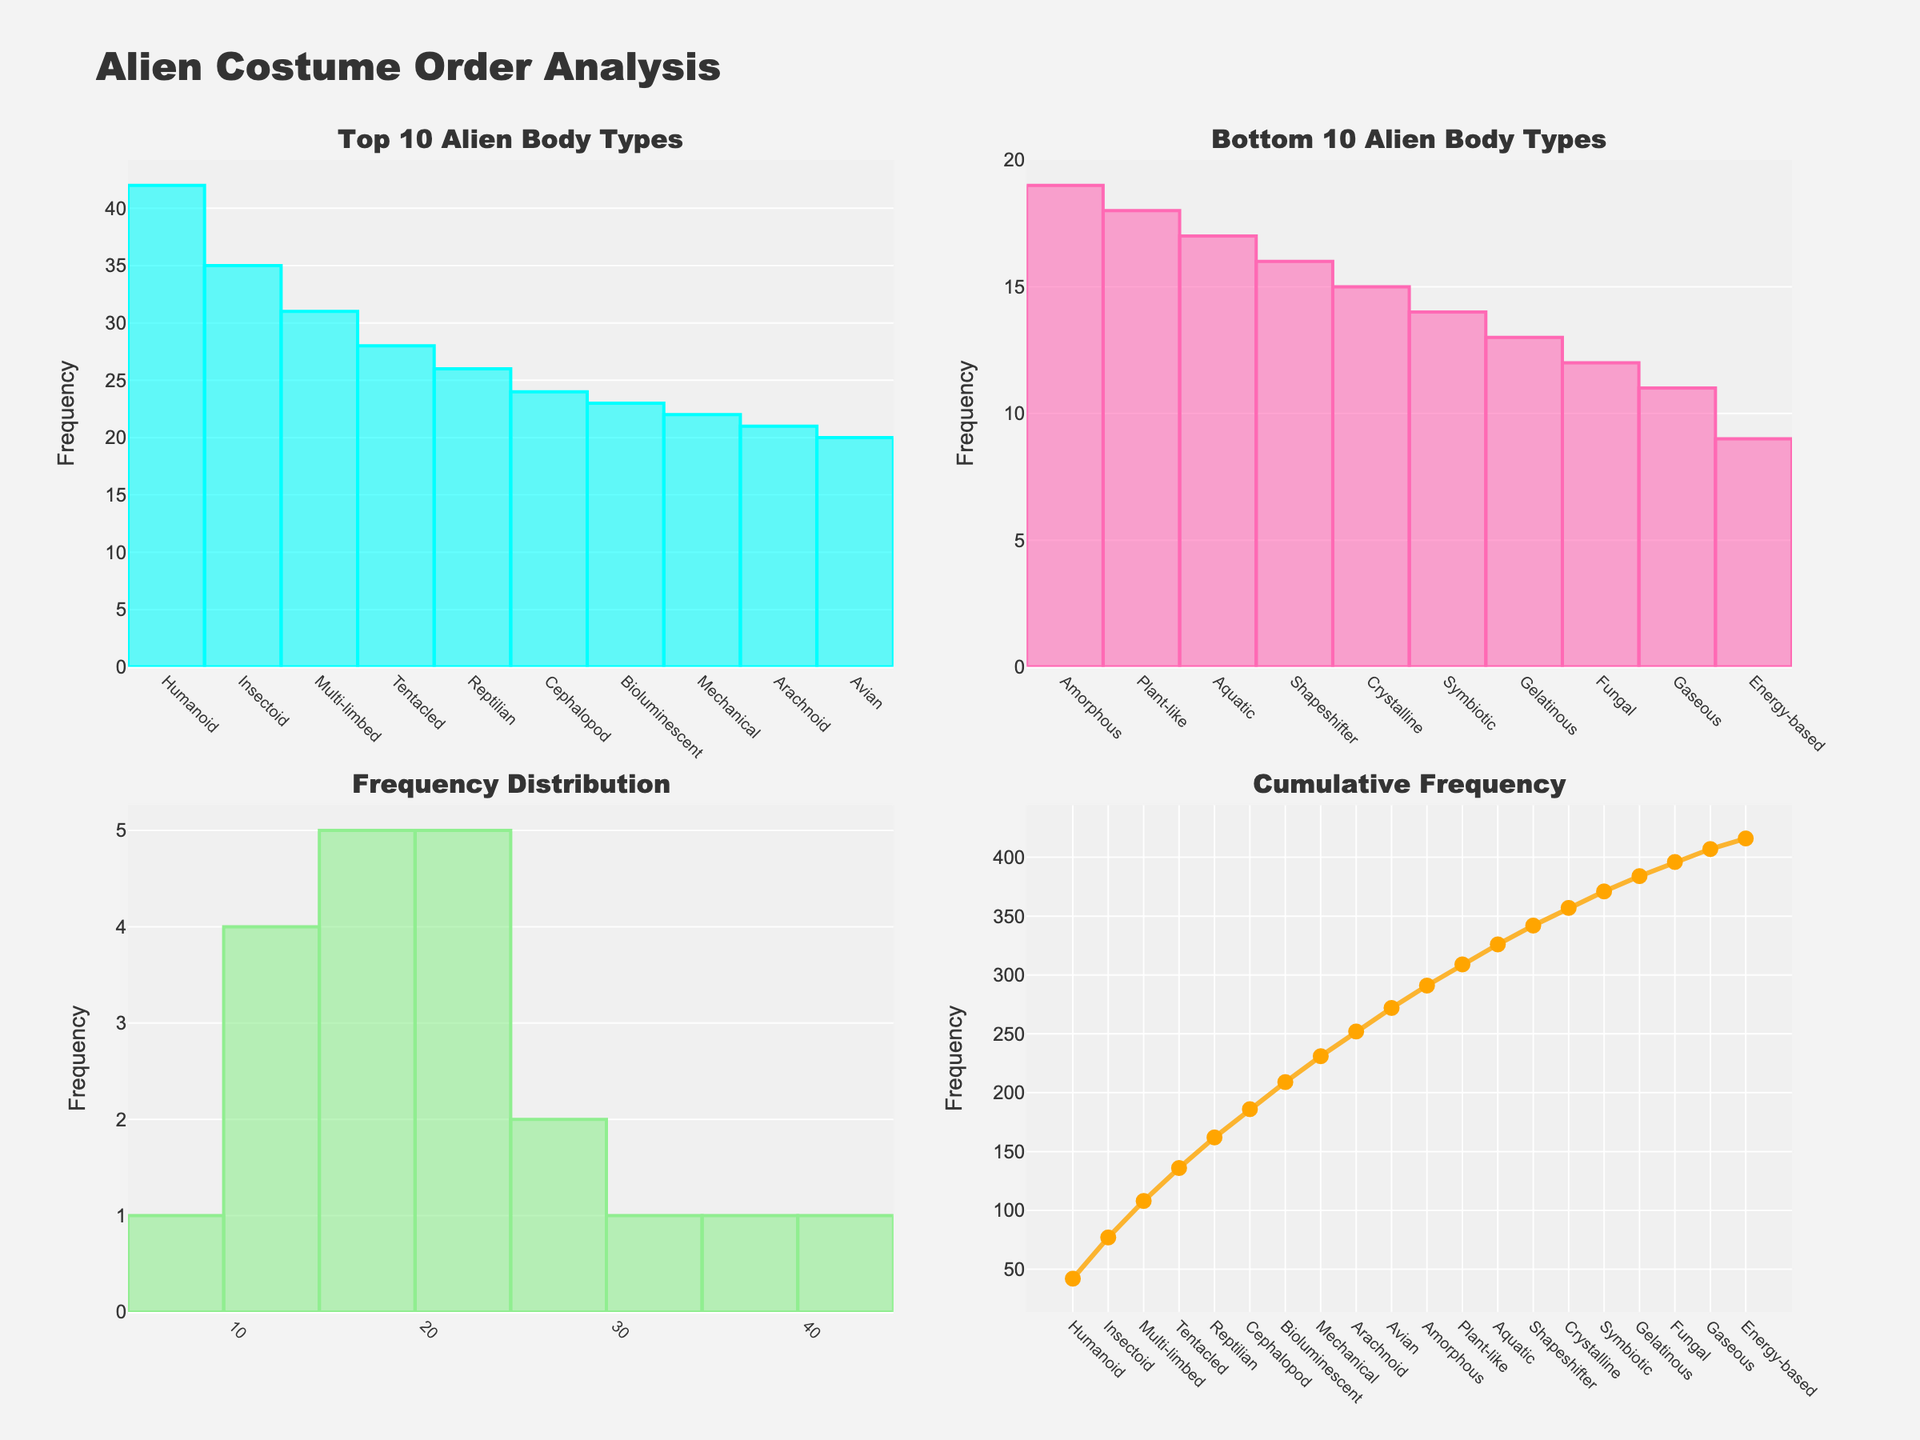What is the most common alien body type in the top 10 categories? Refer to the bar plot in the "Top 10 Alien Body Types" subplot. The tallest bar represents the most common body type, which is Humanoid with a frequency of 42.
Answer: Humanoid Which alien body type has the lowest frequency in the bottom 10 categories? Look at the bar plot in the "Bottom 10 Alien Body Types" subplot. The shortest bar represents the least common body type, which is Energy-based with a frequency of 9.
Answer: Energy-based How many alien body types are there in total? Count the number of unique body types represented in either the "Top 10 Alien Body Types" or "Bottom 10 Alien Body Types" subplots. There are 20 unique body types listed in the data.
Answer: 20 What is the cumulative frequency of Orders after considering the "Reptilian" body type? Refer to the "Cumulative Frequency" plot. Locate the cumulative frequency value at the "Reptilian" point on the x-axis. The cumulative frequency after "Reptilian" is the sum of all frequencies up to and including Reptilian, which is 261.
Answer: 261 Which subplot shows the distribution of order frequencies across all alien body types? Identify the subplot that represents the spread of data across the frequency axis. The "Frequency Distribution" subplot is the one depicting a histogram of frequencies.
Answer: Frequency Distribution Which subplots indicate whether there's a higher concentration of common or rare alien body types in costume orders? Compare the "Top 10 Alien Body Types" and "Bottom 10 Alien Body Types" subplots which show the contrast between the highest and lowest frequencies of orders, indicating concentration dynamics.
Answer: Top 10 Alien Body Types, Bottom 10 Alien Body Types What is the total frequency for the top 10 most ordered alien body types? Sum the frequencies of the bars in the "Top 10 Alien Body Types" subplot. The total is 42 + 35 + 31 + 28 + 26 + 24 + 23 + 22 + 21 + 20 = 272.
Answer: 272 Are the highest and the lowest frequencies more common, or do the frequencies tend to cluster in the middle range? Observe the "Frequency Distribution" subplot to determine the spread of the frequencies. The histogram shows if there is a central tendency or if extremes are more common. Frequencies have a tendency to cluster in the middle range.
Answer: Middle range Which alien body type marks the halfway point in cumulative frequency? Examine the "Cumulative Frequency" plot and find the body type where the cumulative sum is closest to half the total frequency. The total is approximately 373 (sum of all frequencies), so the halfway point is around 186. The body type at this point is Reptilian.
Answer: Reptilian How do the frequencies of the most and least ordered alien body types compare? Compare the tallest bar in the "Top 10 Alien Body Types" subplot and the shortest bar in the "Bottom 10 Alien Body Types" subplot. The frequencies are 42 (Humanoid) and 9 (Energy-based).
Answer: 42 vs. 9 